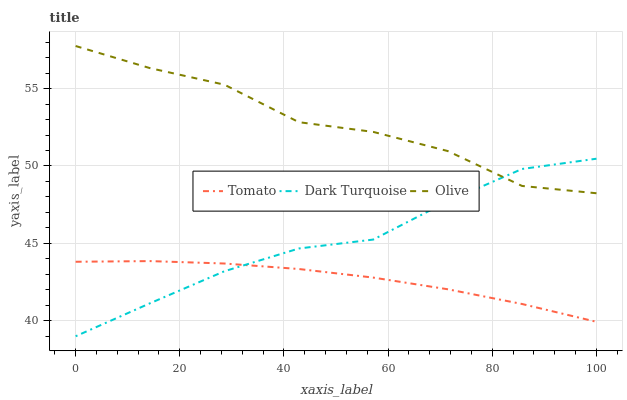Does Tomato have the minimum area under the curve?
Answer yes or no. Yes. Does Olive have the maximum area under the curve?
Answer yes or no. Yes. Does Dark Turquoise have the minimum area under the curve?
Answer yes or no. No. Does Dark Turquoise have the maximum area under the curve?
Answer yes or no. No. Is Tomato the smoothest?
Answer yes or no. Yes. Is Olive the roughest?
Answer yes or no. Yes. Is Dark Turquoise the smoothest?
Answer yes or no. No. Is Dark Turquoise the roughest?
Answer yes or no. No. Does Dark Turquoise have the lowest value?
Answer yes or no. Yes. Does Olive have the lowest value?
Answer yes or no. No. Does Olive have the highest value?
Answer yes or no. Yes. Does Dark Turquoise have the highest value?
Answer yes or no. No. Is Tomato less than Olive?
Answer yes or no. Yes. Is Olive greater than Tomato?
Answer yes or no. Yes. Does Dark Turquoise intersect Olive?
Answer yes or no. Yes. Is Dark Turquoise less than Olive?
Answer yes or no. No. Is Dark Turquoise greater than Olive?
Answer yes or no. No. Does Tomato intersect Olive?
Answer yes or no. No. 